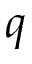<formula> <loc_0><loc_0><loc_500><loc_500>q</formula> 